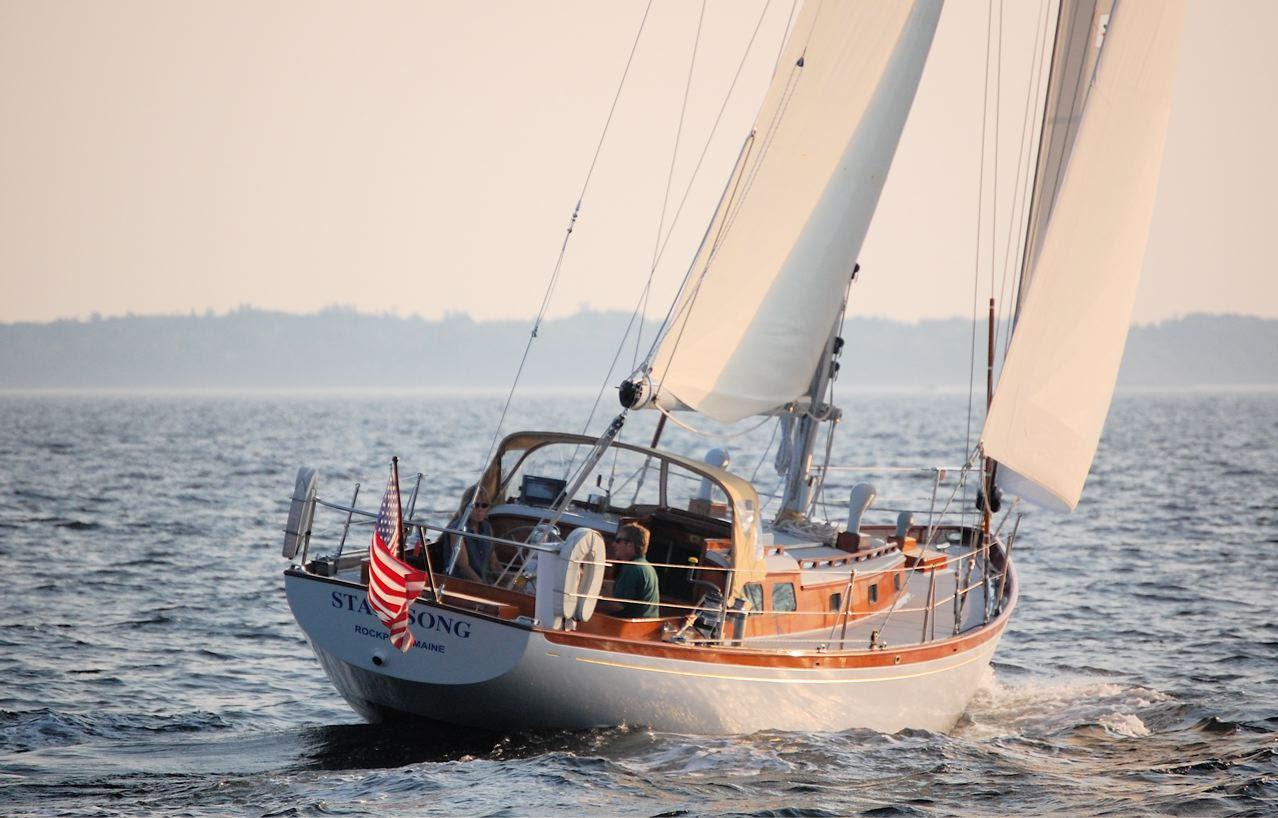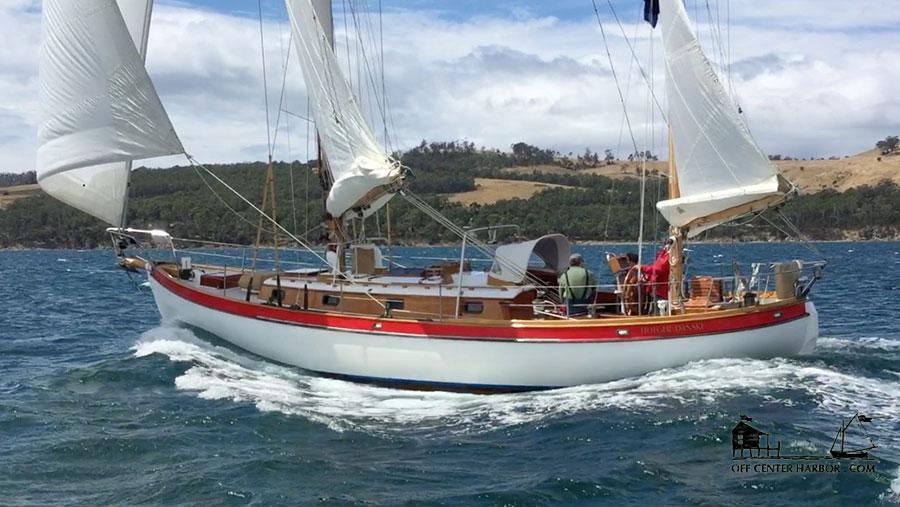The first image is the image on the left, the second image is the image on the right. For the images shown, is this caption "The boat in the image on the left has no sails up." true? Answer yes or no. No. The first image is the image on the left, the second image is the image on the right. Evaluate the accuracy of this statement regarding the images: "The boat in the left image has furled sails, while the boat on the right is moving and creating white spray.". Is it true? Answer yes or no. No. 